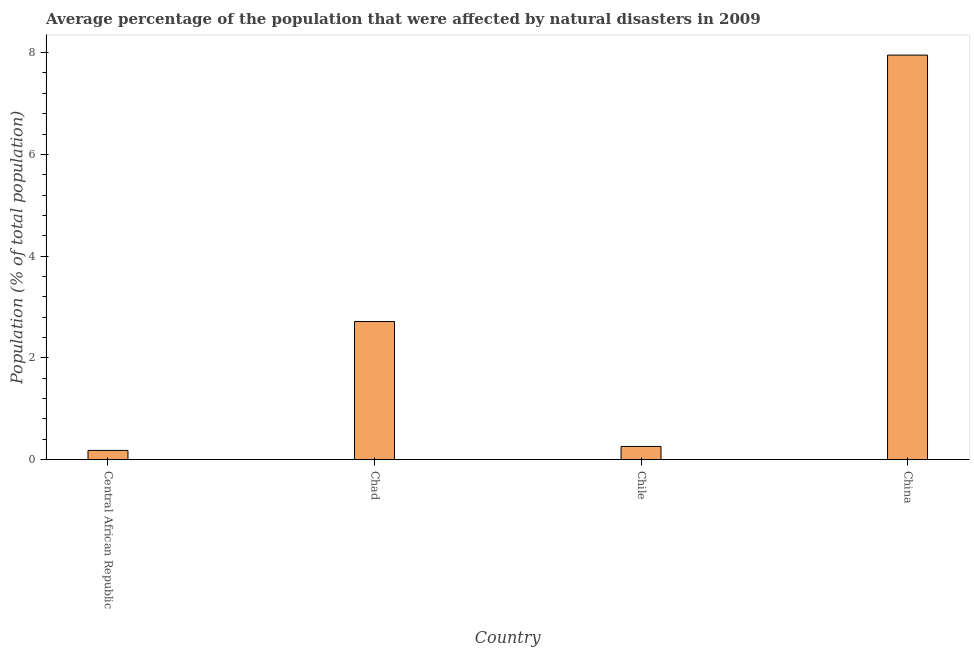What is the title of the graph?
Your answer should be compact. Average percentage of the population that were affected by natural disasters in 2009. What is the label or title of the Y-axis?
Your response must be concise. Population (% of total population). What is the percentage of population affected by droughts in Chile?
Keep it short and to the point. 0.26. Across all countries, what is the maximum percentage of population affected by droughts?
Keep it short and to the point. 7.95. Across all countries, what is the minimum percentage of population affected by droughts?
Offer a very short reply. 0.18. In which country was the percentage of population affected by droughts minimum?
Provide a succinct answer. Central African Republic. What is the sum of the percentage of population affected by droughts?
Provide a short and direct response. 11.11. What is the difference between the percentage of population affected by droughts in Central African Republic and China?
Keep it short and to the point. -7.77. What is the average percentage of population affected by droughts per country?
Provide a short and direct response. 2.78. What is the median percentage of population affected by droughts?
Your response must be concise. 1.49. In how many countries, is the percentage of population affected by droughts greater than 7.2 %?
Your response must be concise. 1. What is the ratio of the percentage of population affected by droughts in Chile to that in China?
Provide a short and direct response. 0.03. Is the difference between the percentage of population affected by droughts in Central African Republic and Chad greater than the difference between any two countries?
Offer a very short reply. No. What is the difference between the highest and the second highest percentage of population affected by droughts?
Your answer should be very brief. 5.24. What is the difference between the highest and the lowest percentage of population affected by droughts?
Offer a terse response. 7.77. In how many countries, is the percentage of population affected by droughts greater than the average percentage of population affected by droughts taken over all countries?
Offer a very short reply. 1. Are all the bars in the graph horizontal?
Keep it short and to the point. No. Are the values on the major ticks of Y-axis written in scientific E-notation?
Your answer should be very brief. No. What is the Population (% of total population) of Central African Republic?
Provide a short and direct response. 0.18. What is the Population (% of total population) in Chad?
Your answer should be compact. 2.71. What is the Population (% of total population) in Chile?
Give a very brief answer. 0.26. What is the Population (% of total population) of China?
Your answer should be very brief. 7.95. What is the difference between the Population (% of total population) in Central African Republic and Chad?
Keep it short and to the point. -2.53. What is the difference between the Population (% of total population) in Central African Republic and Chile?
Your answer should be very brief. -0.08. What is the difference between the Population (% of total population) in Central African Republic and China?
Your response must be concise. -7.77. What is the difference between the Population (% of total population) in Chad and Chile?
Make the answer very short. 2.45. What is the difference between the Population (% of total population) in Chad and China?
Your answer should be very brief. -5.24. What is the difference between the Population (% of total population) in Chile and China?
Offer a very short reply. -7.69. What is the ratio of the Population (% of total population) in Central African Republic to that in Chad?
Your answer should be compact. 0.07. What is the ratio of the Population (% of total population) in Central African Republic to that in Chile?
Make the answer very short. 0.7. What is the ratio of the Population (% of total population) in Central African Republic to that in China?
Ensure brevity in your answer.  0.02. What is the ratio of the Population (% of total population) in Chad to that in Chile?
Offer a very short reply. 10.42. What is the ratio of the Population (% of total population) in Chad to that in China?
Keep it short and to the point. 0.34. What is the ratio of the Population (% of total population) in Chile to that in China?
Provide a short and direct response. 0.03. 